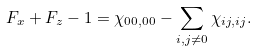Convert formula to latex. <formula><loc_0><loc_0><loc_500><loc_500>F _ { x } + F _ { z } - 1 = \chi _ { 0 0 , 0 0 } - \sum _ { i , j \neq 0 } \chi _ { i j , i j } .</formula> 